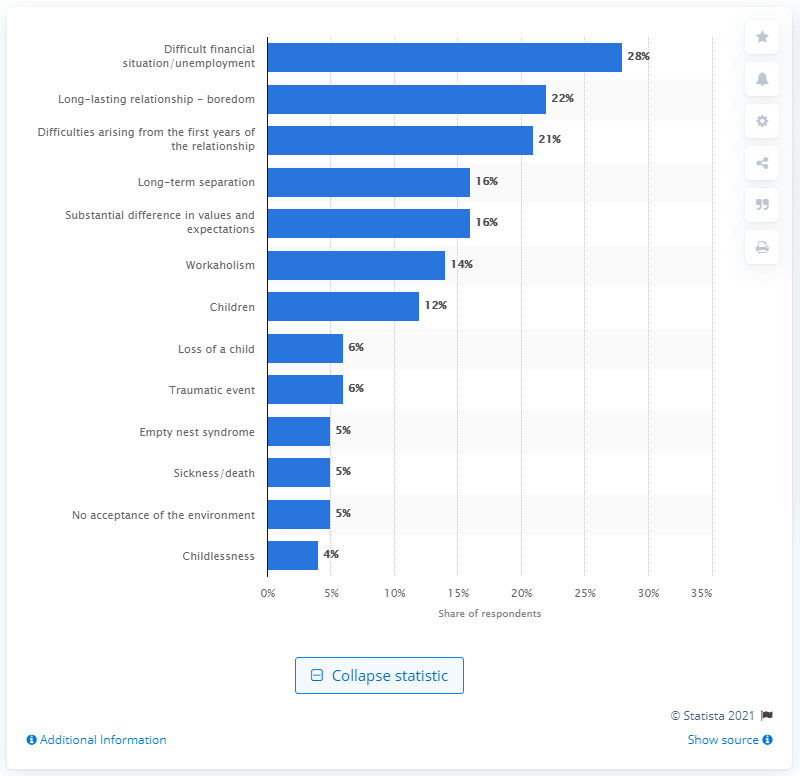Specify some key components in this picture. In 2019, a significant percentage of individuals in Poland reported experiencing boredom and burnout as a result of their long-lasting relationships. 